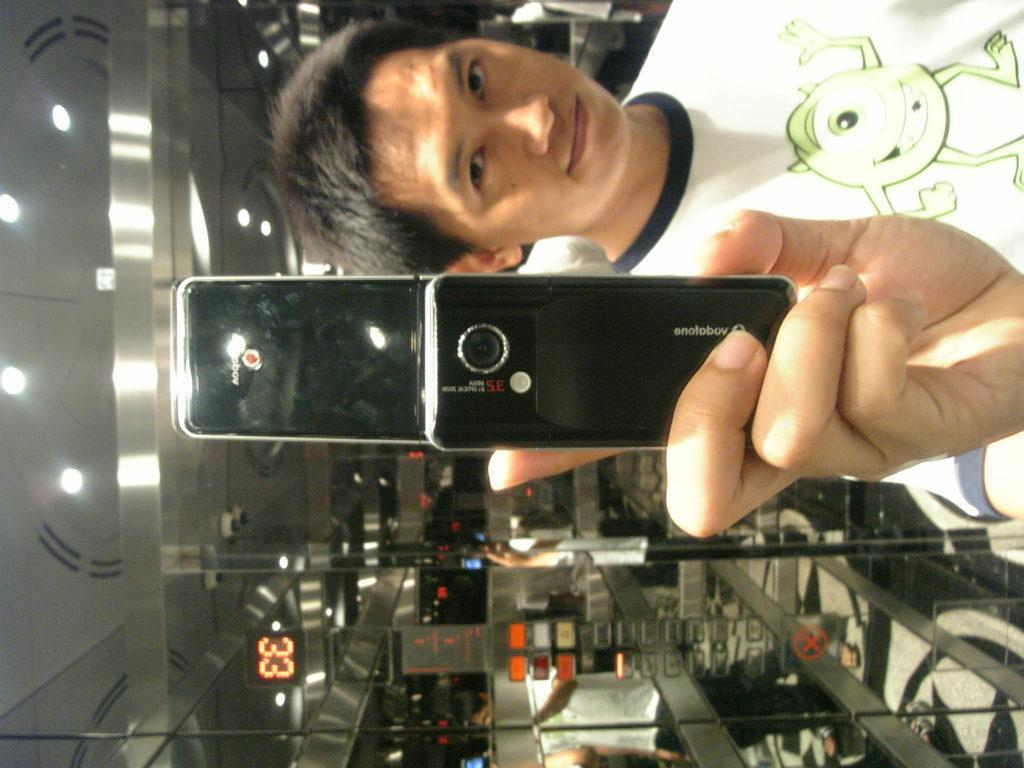Describe this image in one or two sentences. In the picture we can see a man holding a mobile phone, in the background we can see a clock number and lights. 